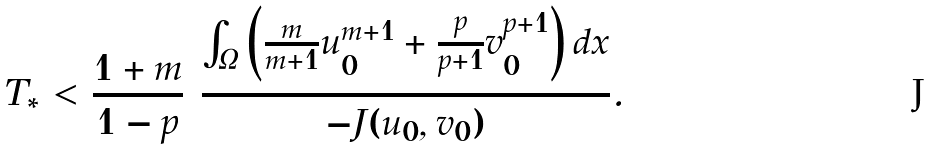Convert formula to latex. <formula><loc_0><loc_0><loc_500><loc_500>T _ { * } < \frac { 1 + m } { 1 - p } \ \frac { \int _ { \Omega } { \left ( { \frac { m } { m + 1 } u _ { 0 } ^ { m + 1 } + \frac { p } { p + 1 } v _ { 0 } ^ { p + 1 } } \right ) d x } } { - J ( u _ { 0 } , v _ { 0 } ) } .</formula> 